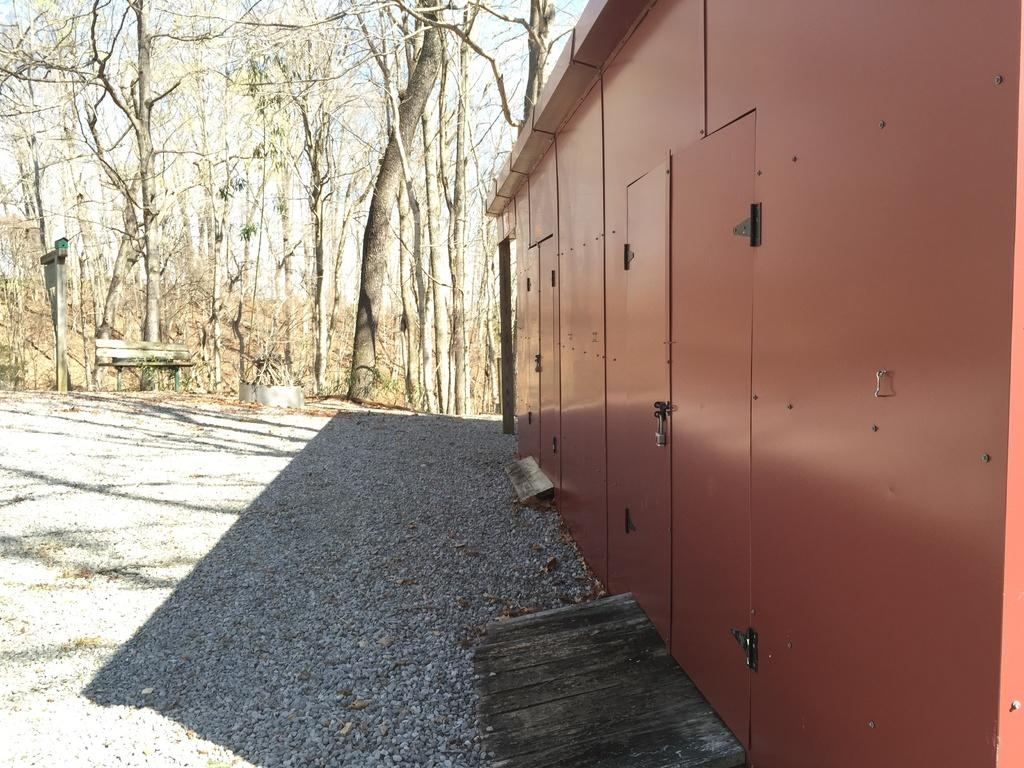What is the color of the house in the image? The house in the image is brown. How can people enter the house? The house has doors for entering. What can be seen in the background of the image? There are trees in the background of the image. Can you see any pickles growing on the trees in the background of the image? There are no pickles visible in the image; the trees in the background are not associated with pickle growth. 